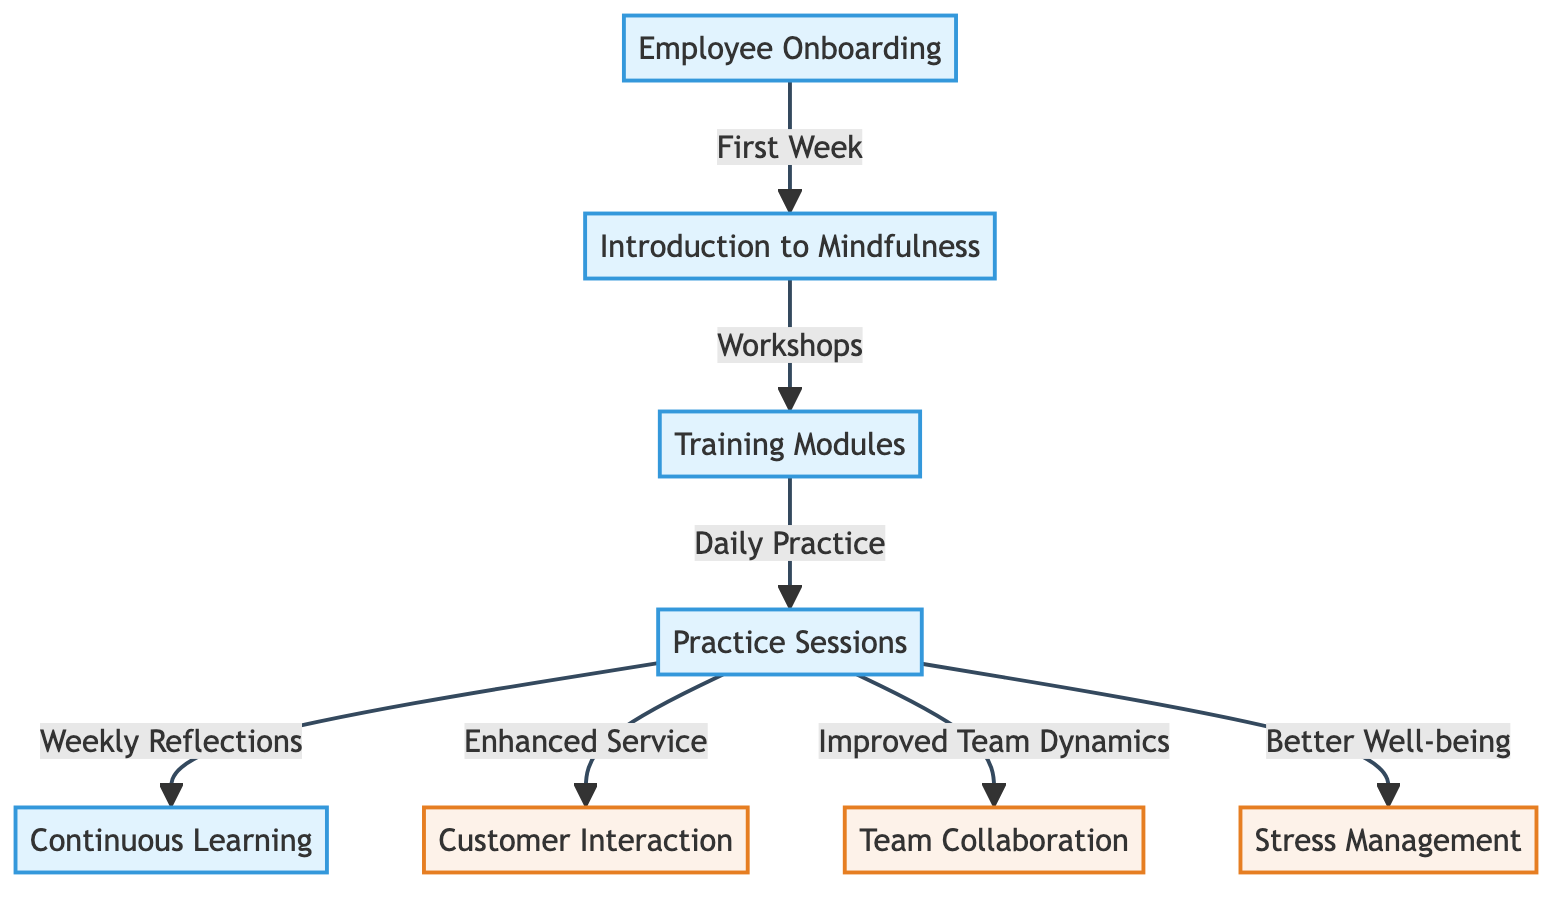What is the first step in the employee mindfulness training workflow? The diagram displays "Employee Onboarding" as the first node, indicating that this is the initial step in the workflow.
Answer: Employee Onboarding How many outcome nodes are present in the diagram? By counting the nodes within the outcome category, there are three outcome nodes: "Customer Interaction," "Team Collaboration," and "Stress Management."
Answer: 3 What is the relationship between "Practice Sessions" and "Enhanced Service"? The diagram shows that "Practice Sessions" directly leads to "Enhanced Service," indicating that enhanced service is a result of engaging in practice sessions.
Answer: Enhanced Service What type of sessions are conducted after the training modules? The diagram indicates that after the training modules, the next step is "Practice Sessions," showing an emphasis on practical application following training.
Answer: Practice Sessions What feedback mechanism is included in the process after practice sessions? The diagram portrays "Weekly Reflections" as a feedback mechanism that follows "Practice Sessions," demonstrating a structured approach to continuous learning and feedback.
Answer: Weekly Reflections Which outcome is directly associated with better well-being? The link from "Practice Sessions" to "Better Well-being" indicates that better well-being is considered an outcome of conducting practice sessions among employees.
Answer: Better Well-being What complements the introduction to mindfulness in the workflow? "Training Modules" directly follows "Introduction to Mindfulness," showing that training modules are a complement or next step in the mindfulness training process.
Answer: Training Modules What is the last step of the workflow in the diagram? The diagram outlines that "Continuous Learning" follows practice sessions, implying it is an ongoing process and therefore the last definitive step in the sequence.
Answer: Continuous Learning How do practice sessions influence team dynamics according to the diagram? The diagram indicates that practice sessions lead to "Improved Team Dynamics," showing a direct influence of practice on how well the team collaborates.
Answer: Improved Team Dynamics 